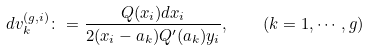<formula> <loc_0><loc_0><loc_500><loc_500>d v ^ { ( g , i ) } _ { k } \colon = \frac { Q ( x _ { i } ) d x _ { i } } { 2 ( x _ { i } - a _ { k } ) Q ^ { \prime } ( a _ { k } ) y _ { i } } , \quad ( k = 1 , \cdots , g )</formula> 